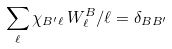<formula> <loc_0><loc_0><loc_500><loc_500>\sum _ { \ell } \chi _ { B ^ { \prime } \ell } \, W ^ { B } _ { \ell } / \ell = \delta _ { B B ^ { \prime } }</formula> 